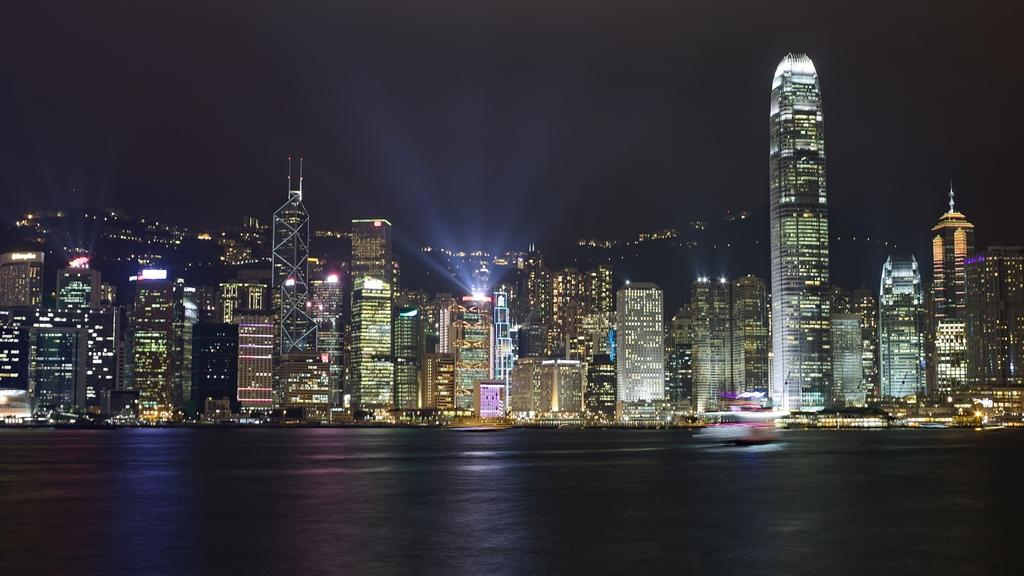What type of structures can be seen in the background of the image? There are buildings in the background of the image. What is visible in the front of the image? There is water visible in the front of the image. How many feet are visible in the image? There are no feet visible in the image. What month is it in the image? The month cannot be determined from the image. 